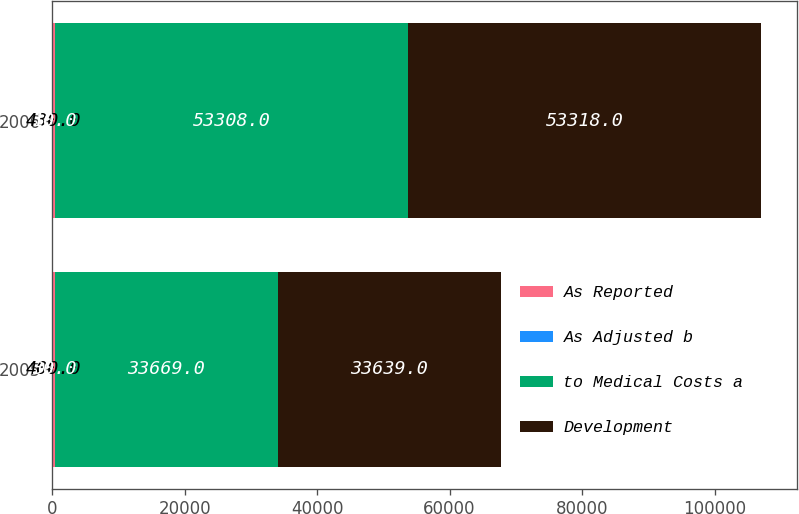Convert chart. <chart><loc_0><loc_0><loc_500><loc_500><stacked_bar_chart><ecel><fcel>2005<fcel>2006<nl><fcel>As Reported<fcel>400<fcel>430<nl><fcel>As Adjusted b<fcel>30<fcel>10<nl><fcel>to Medical Costs a<fcel>33669<fcel>53308<nl><fcel>Development<fcel>33639<fcel>53318<nl></chart> 